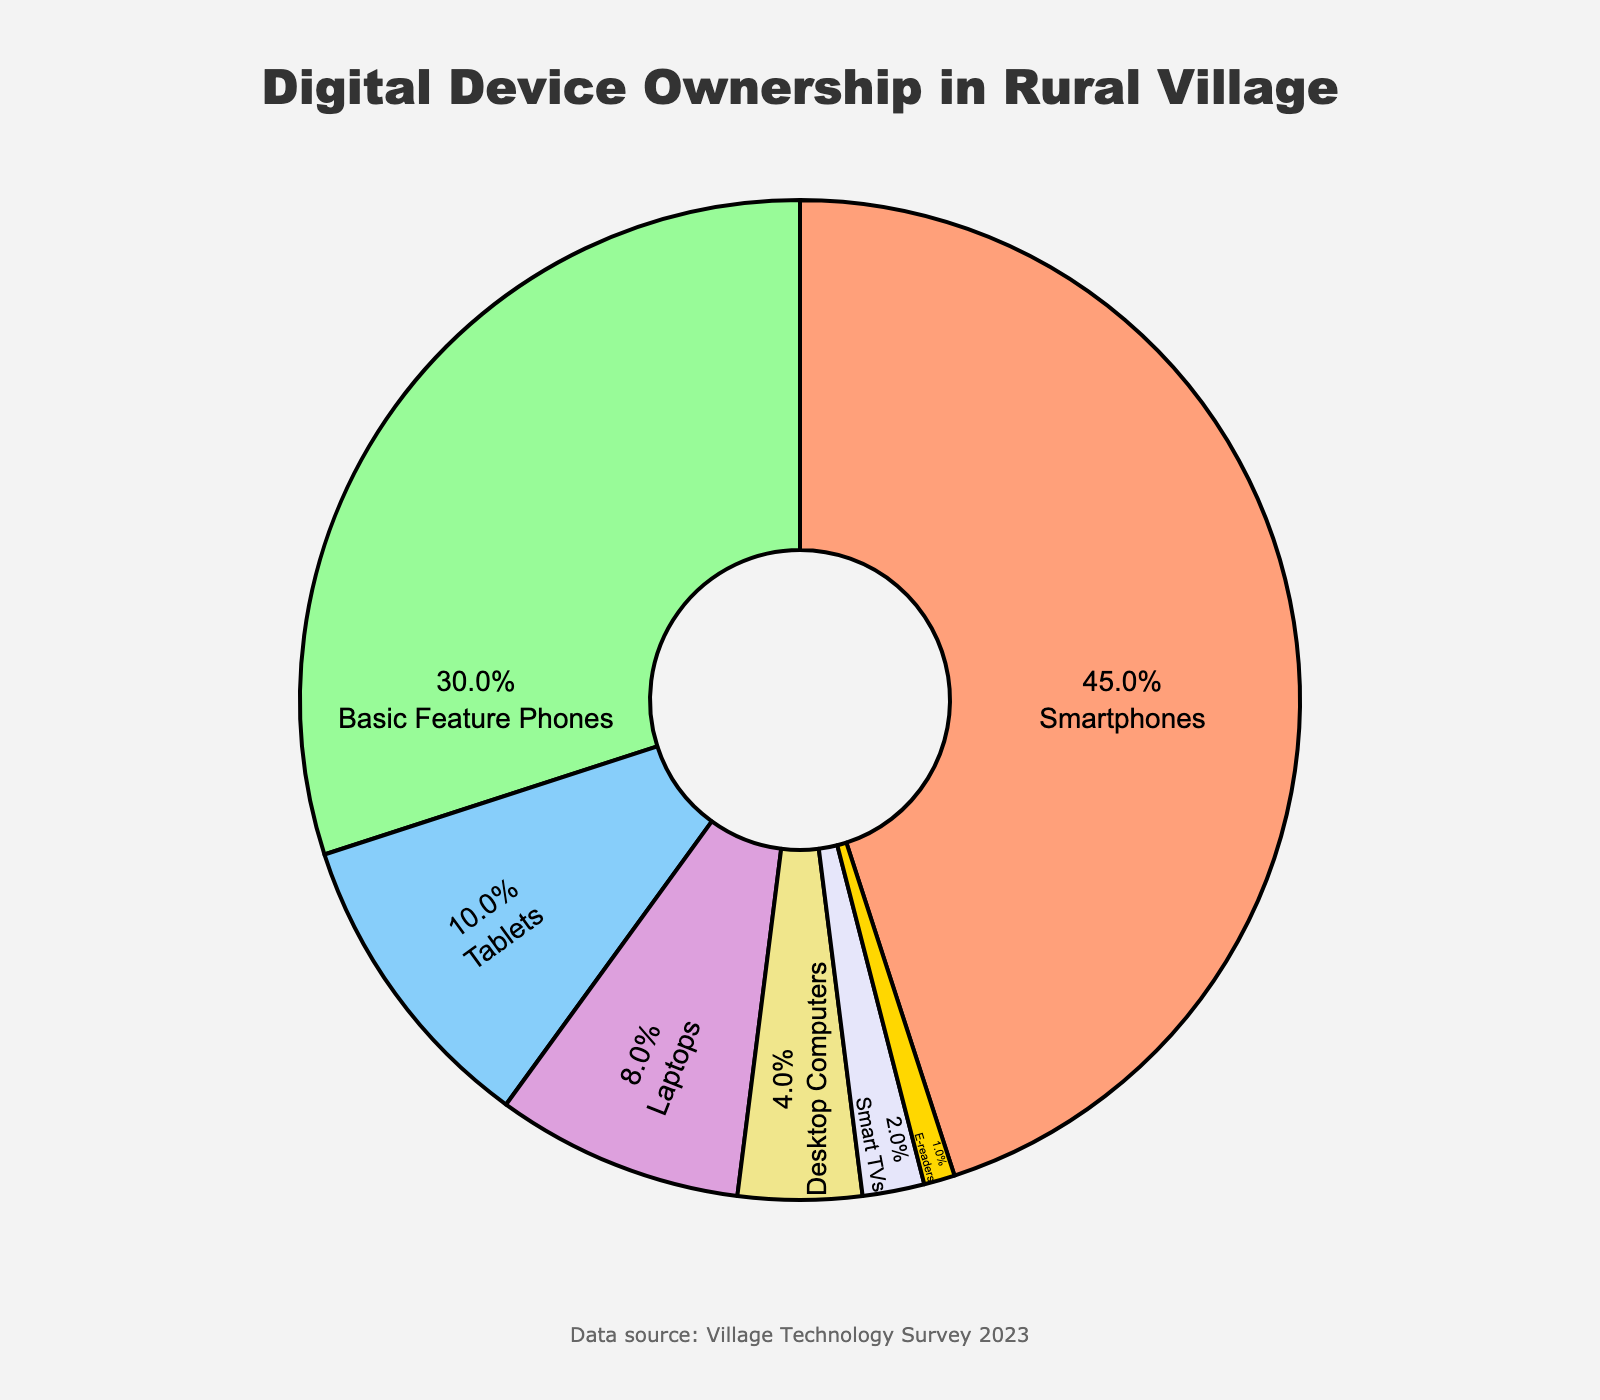What is the most commonly owned digital device in the village? The figure shows the percentage of various digital devices owned by villagers. The largest section of the pie chart represents smartphones.
Answer: Smartphones Which device type is owned by the least number of villagers? By observing the smallest section of the pie chart, it is clear that e-readers have the smallest percentage.
Answer: E-readers How much more common are smartphones compared to tablets? Smartphones account for 45% while tablets account for 10%. The difference is 45% - 10% = 35%.
Answer: 35% Are basic feature phones more common than laptops? Basic feature phones occupy a larger section of the pie chart (30%) compared to laptops (8%).
Answer: Yes If we combine the percentages of ownership for laptops and desktop computers, what total percentage do we get? Laptops make up 8% and desktop computers 4%, so combined they make 8% + 4% = 12%.
Answer: 12% Can you list the devices in descending order of ownership? Listing the devices from the largest to the smallest section of the pie chart: Smartphones (45%), Basic Feature Phones (30%), Tablets (10%), Laptops (8%), Desktop Computers (4%), Smart TVs (2%), E-readers (1%).
Answer: Smartphones, Basic Feature Phones, Tablets, Laptops, Desktop Computers, Smart TVs, E-readers How many times more common are smart TVs than e-readers? Smart TVs account for 2% while e-readers account for 1%. 2% divided by 1% is 2, so smart TVs are twice as common as e-readers.
Answer: 2 times Which device types, when combined, make up less than a quarter of the total ownership? Adding up the percentages of the smallest categories: Desktop Computers (4%), Smart TVs (2%), E-readers (1%) gives 4% + 2% + 1% = 7%. Tablets (10%) and Laptops (8%) combined give 18%. Therefore, the combination of Desktop Computers, Smart TVs, and E-readers totals 7% which is less than 25% or a quarter.
Answer: Desktop Computers, Smart TVs, E-readers What percentage more common is the ownership of smartphones compared to basic feature phones and smart TVs combined? The percentages are 45% for smartphones, 30% for basic feature phones, and 2% for smart TVs. Combined percentage for basic feature phones and smart TVs is 30% + 2% = 32%. Therefore, smartphones are 45% - 32% = 13% more common.
Answer: 13% 